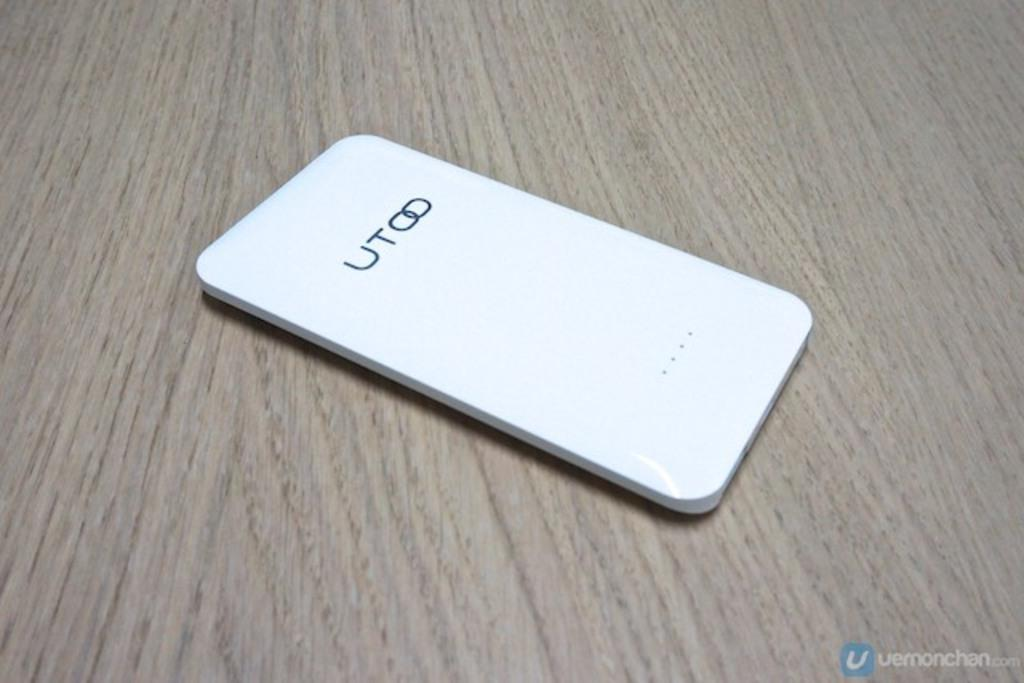What is the main subject of the image? There is a device on a wooden board in the image. Can you describe the device in more detail? Unfortunately, the image does not provide enough detail to describe the device further. Is there any additional information about the image? Yes, there is a watermark on the image. How many ducks are sitting on the hydrant in the image? There are no ducks or hydrants present in the image. What type of jelly is being used to hold the device in place on the wooden board? There is no jelly visible in the image, and the device appears to be resting on the wooden board without any additional support. 